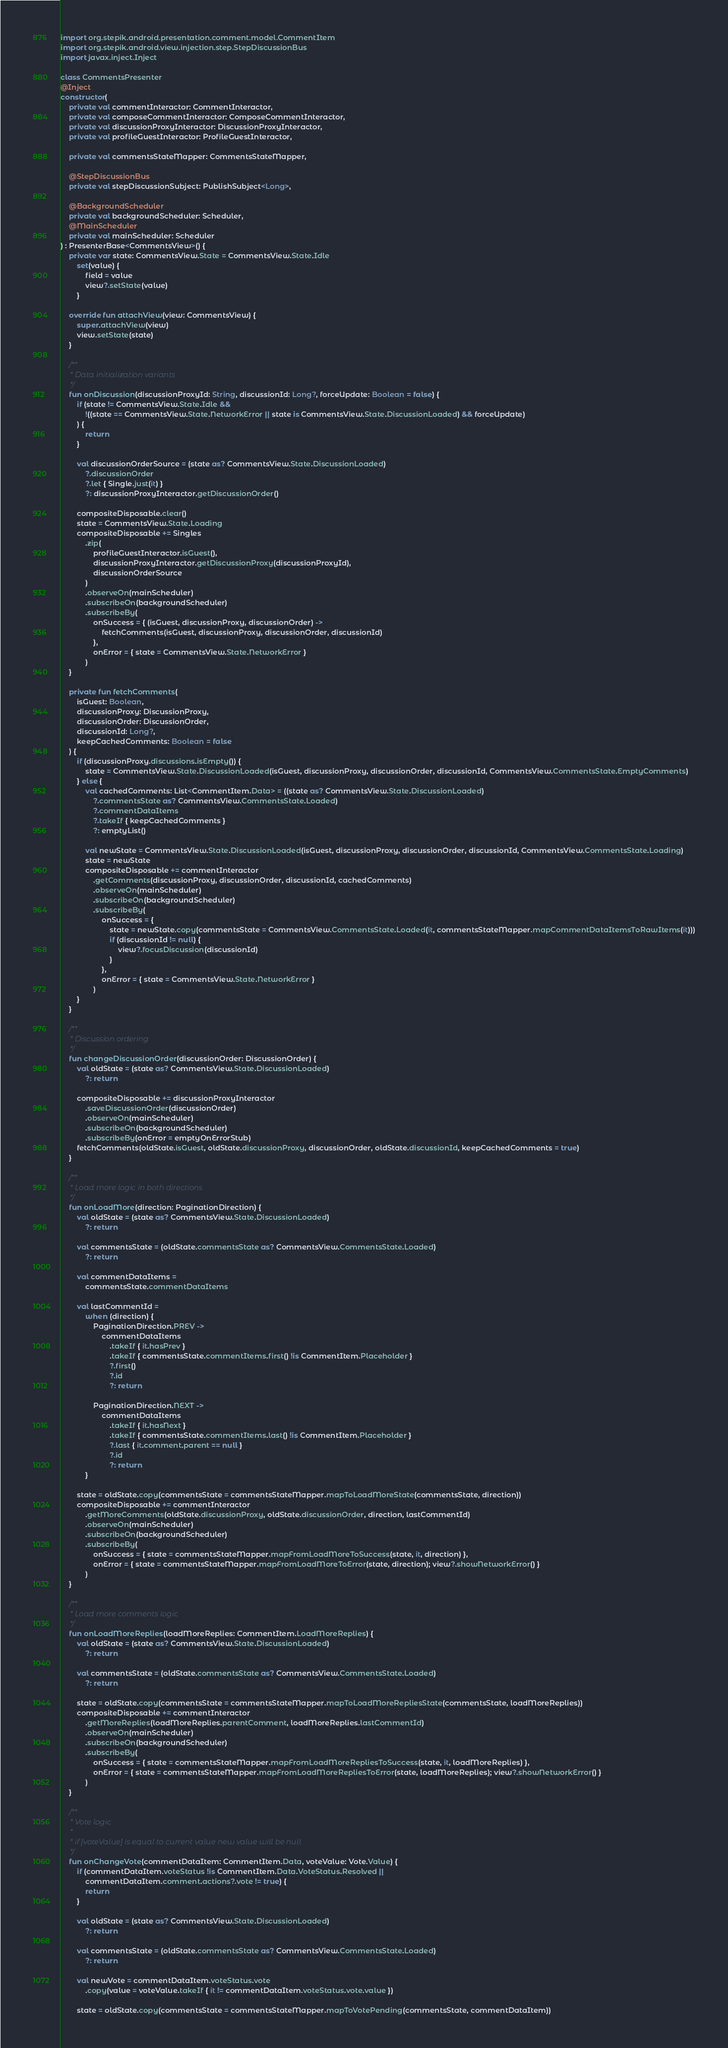Convert code to text. <code><loc_0><loc_0><loc_500><loc_500><_Kotlin_>import org.stepik.android.presentation.comment.model.CommentItem
import org.stepik.android.view.injection.step.StepDiscussionBus
import javax.inject.Inject

class CommentsPresenter
@Inject
constructor(
    private val commentInteractor: CommentInteractor,
    private val composeCommentInteractor: ComposeCommentInteractor,
    private val discussionProxyInteractor: DiscussionProxyInteractor,
    private val profileGuestInteractor: ProfileGuestInteractor,

    private val commentsStateMapper: CommentsStateMapper,

    @StepDiscussionBus
    private val stepDiscussionSubject: PublishSubject<Long>,

    @BackgroundScheduler
    private val backgroundScheduler: Scheduler,
    @MainScheduler
    private val mainScheduler: Scheduler
) : PresenterBase<CommentsView>() {
    private var state: CommentsView.State = CommentsView.State.Idle
        set(value) {
            field = value
            view?.setState(value)
        }

    override fun attachView(view: CommentsView) {
        super.attachView(view)
        view.setState(state)
    }

    /**
     * Data initialization variants
     */
    fun onDiscussion(discussionProxyId: String, discussionId: Long?, forceUpdate: Boolean = false) {
        if (state != CommentsView.State.Idle &&
            !((state == CommentsView.State.NetworkError || state is CommentsView.State.DiscussionLoaded) && forceUpdate)
        ) {
            return
        }

        val discussionOrderSource = (state as? CommentsView.State.DiscussionLoaded)
            ?.discussionOrder
            ?.let { Single.just(it) }
            ?: discussionProxyInteractor.getDiscussionOrder()

        compositeDisposable.clear()
        state = CommentsView.State.Loading
        compositeDisposable += Singles
            .zip(
                profileGuestInteractor.isGuest(),
                discussionProxyInteractor.getDiscussionProxy(discussionProxyId),
                discussionOrderSource
            )
            .observeOn(mainScheduler)
            .subscribeOn(backgroundScheduler)
            .subscribeBy(
                onSuccess = { (isGuest, discussionProxy, discussionOrder) ->
                    fetchComments(isGuest, discussionProxy, discussionOrder, discussionId)
                },
                onError = { state = CommentsView.State.NetworkError }
            )
    }

    private fun fetchComments(
        isGuest: Boolean,
        discussionProxy: DiscussionProxy,
        discussionOrder: DiscussionOrder,
        discussionId: Long?,
        keepCachedComments: Boolean = false
    ) {
        if (discussionProxy.discussions.isEmpty()) {
            state = CommentsView.State.DiscussionLoaded(isGuest, discussionProxy, discussionOrder, discussionId, CommentsView.CommentsState.EmptyComments)
        } else {
            val cachedComments: List<CommentItem.Data> = ((state as? CommentsView.State.DiscussionLoaded)
                ?.commentsState as? CommentsView.CommentsState.Loaded)
                ?.commentDataItems
                ?.takeIf { keepCachedComments }
                ?: emptyList()

            val newState = CommentsView.State.DiscussionLoaded(isGuest, discussionProxy, discussionOrder, discussionId, CommentsView.CommentsState.Loading)
            state = newState
            compositeDisposable += commentInteractor
                .getComments(discussionProxy, discussionOrder, discussionId, cachedComments)
                .observeOn(mainScheduler)
                .subscribeOn(backgroundScheduler)
                .subscribeBy(
                    onSuccess = {
                        state = newState.copy(commentsState = CommentsView.CommentsState.Loaded(it, commentsStateMapper.mapCommentDataItemsToRawItems(it)))
                        if (discussionId != null) {
                            view?.focusDiscussion(discussionId)
                        }
                    },
                    onError = { state = CommentsView.State.NetworkError }
                )
        }
    }

    /**
     * Discussion ordering
     */
    fun changeDiscussionOrder(discussionOrder: DiscussionOrder) {
        val oldState = (state as? CommentsView.State.DiscussionLoaded)
            ?: return

        compositeDisposable += discussionProxyInteractor
            .saveDiscussionOrder(discussionOrder)
            .observeOn(mainScheduler)
            .subscribeOn(backgroundScheduler)
            .subscribeBy(onError = emptyOnErrorStub)
        fetchComments(oldState.isGuest, oldState.discussionProxy, discussionOrder, oldState.discussionId, keepCachedComments = true)
    }

    /**
     * Load more logic in both directions
     */
    fun onLoadMore(direction: PaginationDirection) {
        val oldState = (state as? CommentsView.State.DiscussionLoaded)
            ?: return

        val commentsState = (oldState.commentsState as? CommentsView.CommentsState.Loaded)
            ?: return

        val commentDataItems =
            commentsState.commentDataItems

        val lastCommentId =
            when (direction) {
                PaginationDirection.PREV ->
                    commentDataItems
                        .takeIf { it.hasPrev }
                        .takeIf { commentsState.commentItems.first() !is CommentItem.Placeholder }
                        ?.first()
                        ?.id
                        ?: return

                PaginationDirection.NEXT ->
                    commentDataItems
                        .takeIf { it.hasNext }
                        .takeIf { commentsState.commentItems.last() !is CommentItem.Placeholder }
                        ?.last { it.comment.parent == null }
                        ?.id
                        ?: return
            }

        state = oldState.copy(commentsState = commentsStateMapper.mapToLoadMoreState(commentsState, direction))
        compositeDisposable += commentInteractor
            .getMoreComments(oldState.discussionProxy, oldState.discussionOrder, direction, lastCommentId)
            .observeOn(mainScheduler)
            .subscribeOn(backgroundScheduler)
            .subscribeBy(
                onSuccess = { state = commentsStateMapper.mapFromLoadMoreToSuccess(state, it, direction) },
                onError = { state = commentsStateMapper.mapFromLoadMoreToError(state, direction); view?.showNetworkError() }
            )
    }

    /**
     * Load more comments logic
     */
    fun onLoadMoreReplies(loadMoreReplies: CommentItem.LoadMoreReplies) {
        val oldState = (state as? CommentsView.State.DiscussionLoaded)
            ?: return

        val commentsState = (oldState.commentsState as? CommentsView.CommentsState.Loaded)
            ?: return

        state = oldState.copy(commentsState = commentsStateMapper.mapToLoadMoreRepliesState(commentsState, loadMoreReplies))
        compositeDisposable += commentInteractor
            .getMoreReplies(loadMoreReplies.parentComment, loadMoreReplies.lastCommentId)
            .observeOn(mainScheduler)
            .subscribeOn(backgroundScheduler)
            .subscribeBy(
                onSuccess = { state = commentsStateMapper.mapFromLoadMoreRepliesToSuccess(state, it, loadMoreReplies) },
                onError = { state = commentsStateMapper.mapFromLoadMoreRepliesToError(state, loadMoreReplies); view?.showNetworkError() }
            )
    }

    /**
     * Vote logic
     *
     * if [voteValue] is equal to current value new value will be null
     */
    fun onChangeVote(commentDataItem: CommentItem.Data, voteValue: Vote.Value) {
        if (commentDataItem.voteStatus !is CommentItem.Data.VoteStatus.Resolved ||
            commentDataItem.comment.actions?.vote != true) {
            return
        }

        val oldState = (state as? CommentsView.State.DiscussionLoaded)
            ?: return

        val commentsState = (oldState.commentsState as? CommentsView.CommentsState.Loaded)
            ?: return

        val newVote = commentDataItem.voteStatus.vote
            .copy(value = voteValue.takeIf { it != commentDataItem.voteStatus.vote.value })

        state = oldState.copy(commentsState = commentsStateMapper.mapToVotePending(commentsState, commentDataItem))</code> 